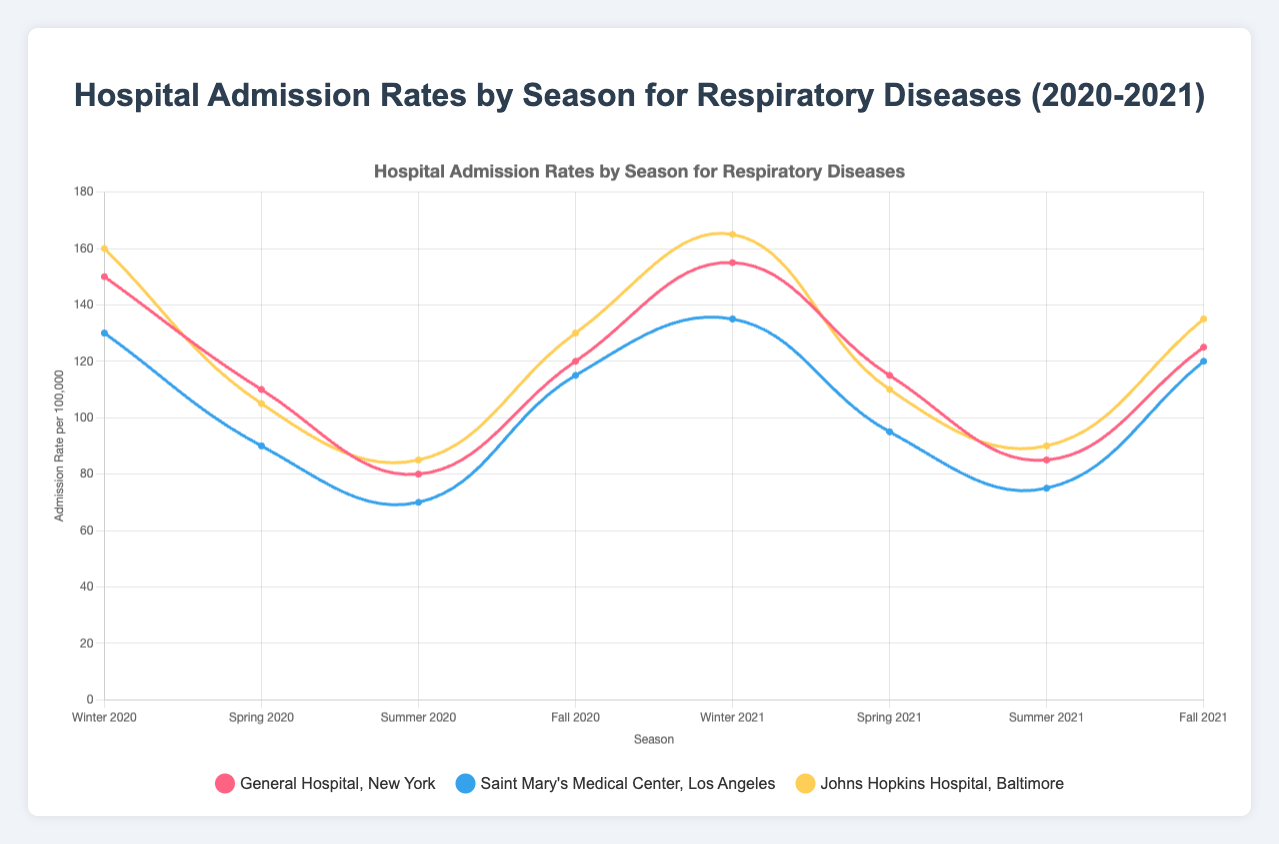Which season had the highest admission rate at General Hospital in New York in 2020? In the figure, the admission rates at General Hospital in New York for each season in 2020 are 150 (Winter), 110 (Spring), 80 (Summer), and 120 (Fall). So, the highest admission rate is in the Winter with 150.
Answer: Winter Which hospital had the lowest admission rate in Summer 2021? The admission rates for Summer 2021 in the figure are 85 (General Hospital, New York), 75 (Saint Mary's Medical Center, Los Angeles), and 90 (Johns Hopkins Hospital, Baltimore). Saint Mary's Medical Center has the lowest admission rate with 75.
Answer: Saint Mary's Medical Center, Los Angeles What was the average admission rate for respiratory diseases at Johns Hopkins Hospital, Baltimore across all seasons in 2021? The admission rates for Johns Hopkins Hospital in 2021 are 165 (Winter), 110 (Spring), 90 (Summer), and 135 (Fall). To get the average, sum them: 165 + 110 + 90 + 135 = 500, and then divide by 4 (the number of seasons), resulting in an average of 125.
Answer: 125 What is the difference in admission rates between Winter 2021 and Summer 2021 for Saint Mary’s Medical Center, Los Angeles? The admission rates for Saint Mary's Medical Center, Los Angeles are 135 in Winter 2021 and 75 in Summer 2021. The difference is calculated as 135 - 75 = 60.
Answer: 60 Which line in the figure has the steepest decrease between Winter and Spring in 2020? By examining the lines for each hospital between Winter 2020 and Spring 2020, General Hospital, New York decreases from 150 to 110 (40 units drop), Saint Mary's Medical Center, Los Angeles from 130 to 90 (40 units), Johns Hopkins Hospital, Baltimore from 160 to 105 (55 units drop). The steepest decrease is seen in Johns Hopkins Hospital.
Answer: Johns Hopkins Hospital, Baltimore What color represents admission rates at General Hospital, New York? In the figure, General Hospital, New York is represented by the red line. This is evident from the legend showing the color association to the hospital names.
Answer: Red Between Fall 2020 and Fall 2021, which hospital showed the most significant increase in admission rates? The admission rates for Fall 2020 and Fall 2021 are as follows: General Hospital, New York (120 to 125; 5 units increment), Saint Mary’s Medical Center, Los Angeles (115 to 120; 5 units increment), and Johns Hopkins Hospital, Baltimore (130 to 135; 5 units increment). Since all three hospitals show a 5-unit incremental increase, there is no most significant increase as they all increased equally.
Answer: All equally What is the total sum of admission rates across all hospitals in Spring 2021? The admission rates for Spring 2021 are as follows: General Hospital, New York (115), Saint Mary’s Medical Center, Los Angeles (95), and Johns Hopkins Hospital, Baltimore (110). The total sum is calculated as 115 + 95 + 110 = 320.
Answer: 320 